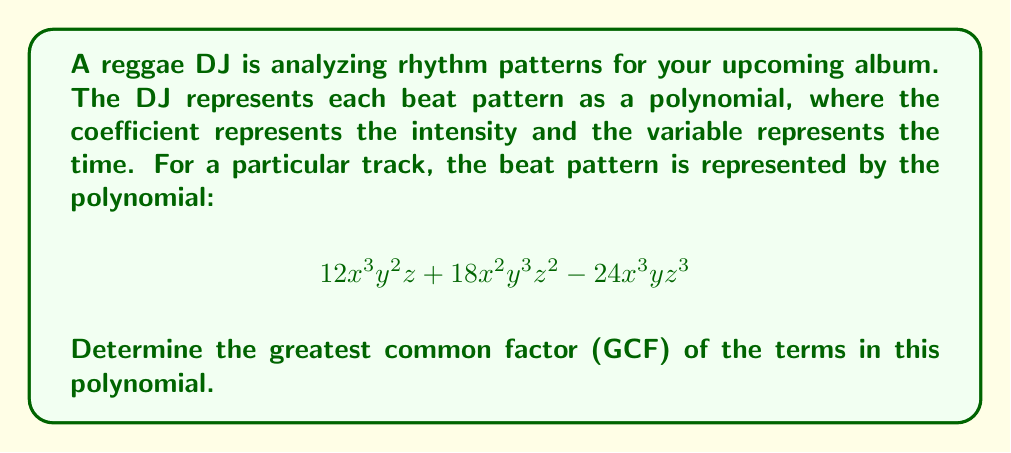Could you help me with this problem? To find the greatest common factor of the terms in the polynomial, we need to follow these steps:

1. Identify the terms:
   Term 1: $12x^3y^2z$
   Term 2: $18x^2y^3z^2$
   Term 3: $-24x^3yz^3$

2. Find the GCF of the coefficients:
   GCF(12, 18, -24) = 6

3. Find the common variables with their lowest exponents:
   x: lowest exponent is 2
   y: lowest exponent is 1
   z: lowest exponent is 1

4. Combine the GCF of coefficients with the common variables:
   $6x^2yz$

This factor $6x^2yz$ is common to all terms in the polynomial and is the greatest such factor.

5. Verify by dividing each term by the GCF:
   $12x^3y^2z \div 6x^2yz = 2xy$
   $18x^2y^3z^2 \div 6x^2yz = 3y^2z$
   $-24x^3yz^3 \div 6x^2yz = -4xz^2$

The GCF $6x^2yz$ divides evenly into each term, confirming it is correct.
Answer: $6x^2yz$ 